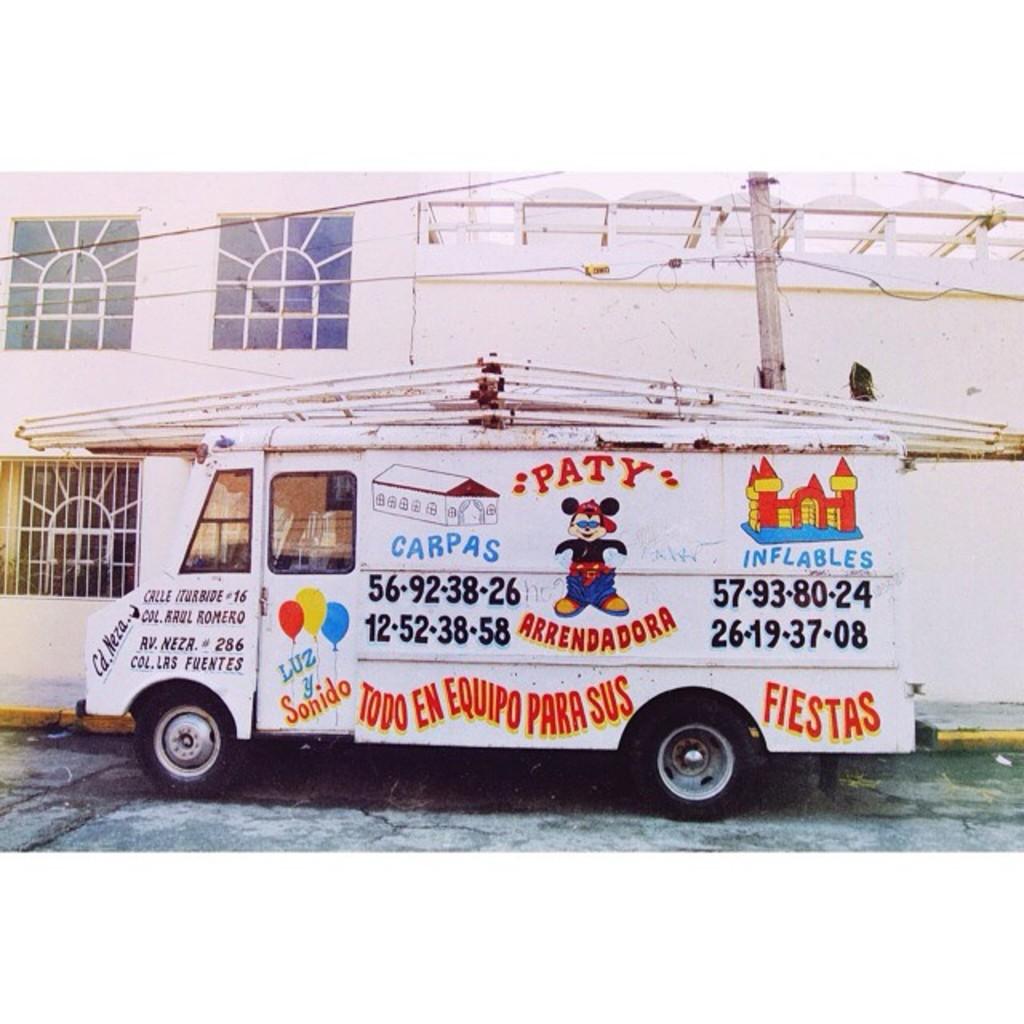What service does this van provide?
Keep it short and to the point. Fiestas. What is the business name on the truck?
Provide a succinct answer. Paty arrendadora. 